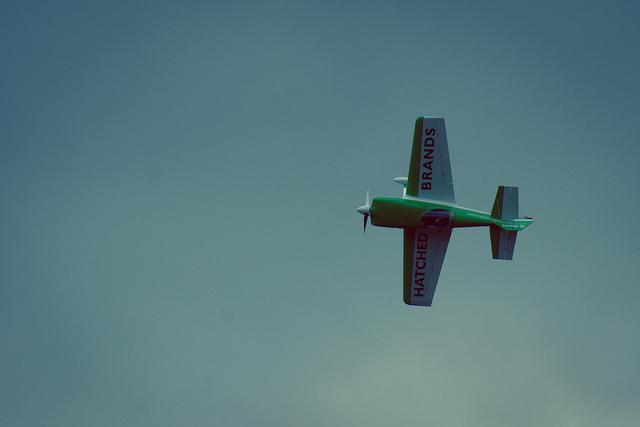How many engines does the plane have?
Give a very brief answer. 1. 